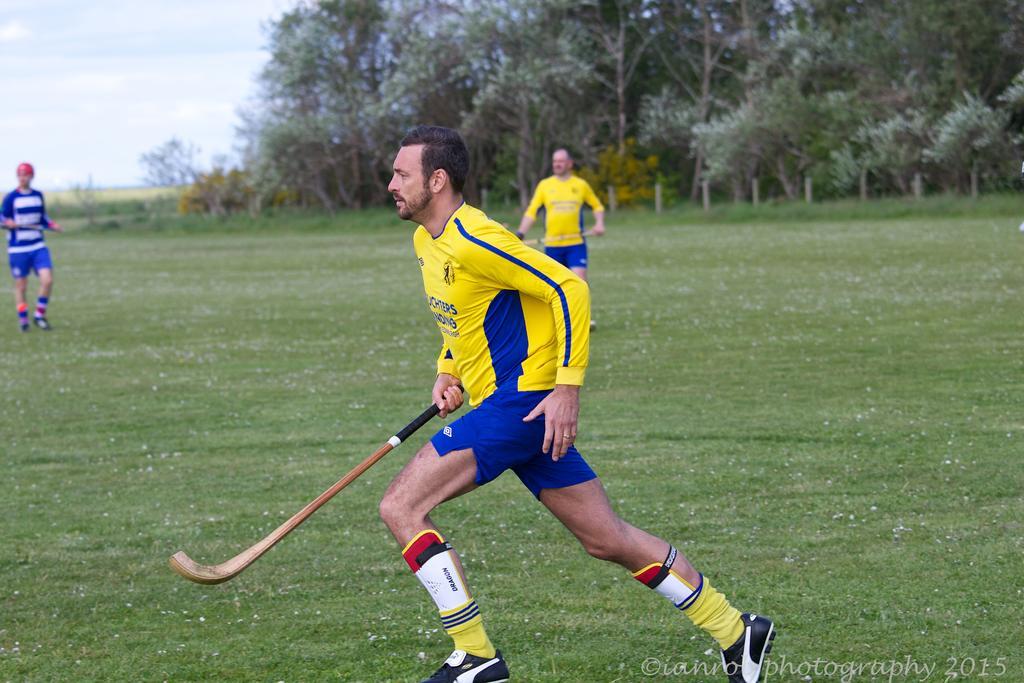Could you give a brief overview of what you see in this image? In this image we can see the player holding the hockey stick and running on the playground. We can also see two other players in the playground. Image also consists of trees, some wooden rods, grass and also the sky. In the bottom right corner there is text. 